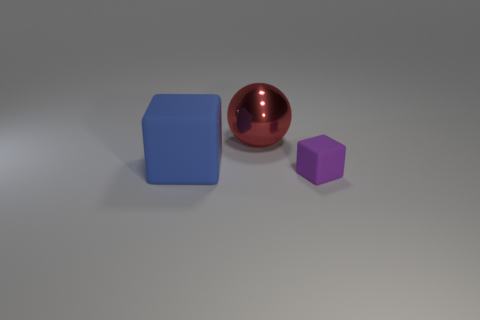Add 3 small brown cubes. How many objects exist? 6 Subtract all balls. How many objects are left? 2 Add 2 tiny things. How many tiny things are left? 3 Add 2 big green metallic balls. How many big green metallic balls exist? 2 Subtract 0 yellow cubes. How many objects are left? 3 Subtract all shiny things. Subtract all red spheres. How many objects are left? 1 